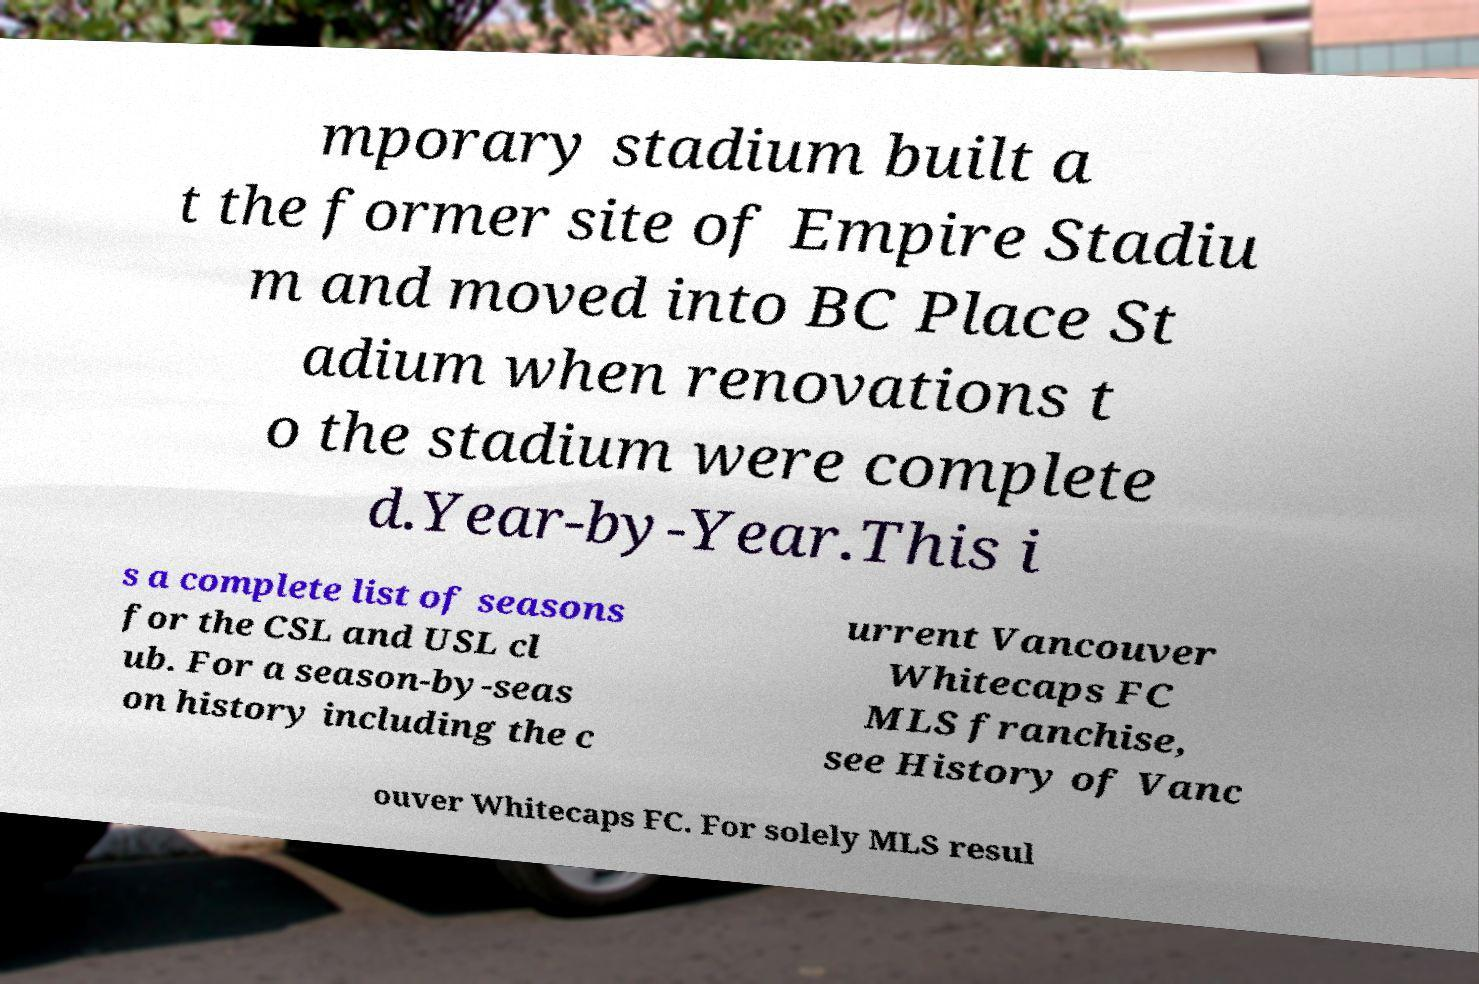Please identify and transcribe the text found in this image. mporary stadium built a t the former site of Empire Stadiu m and moved into BC Place St adium when renovations t o the stadium were complete d.Year-by-Year.This i s a complete list of seasons for the CSL and USL cl ub. For a season-by-seas on history including the c urrent Vancouver Whitecaps FC MLS franchise, see History of Vanc ouver Whitecaps FC. For solely MLS resul 